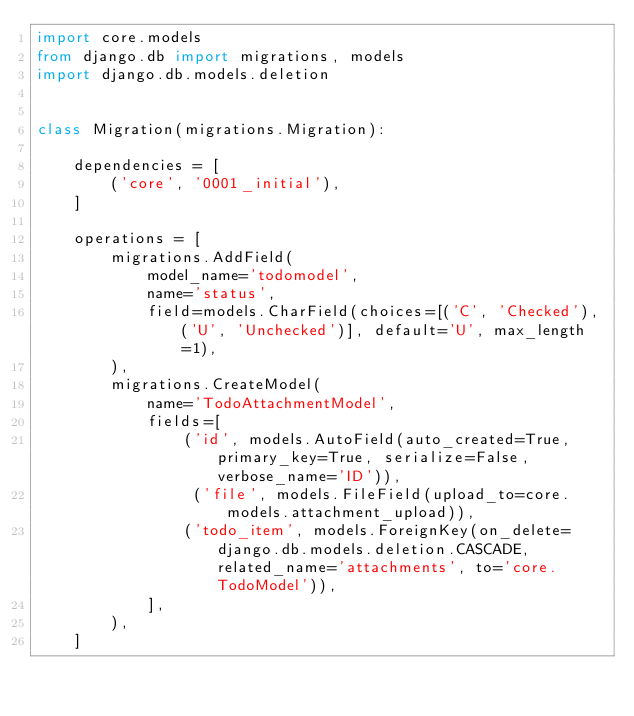<code> <loc_0><loc_0><loc_500><loc_500><_Python_>import core.models
from django.db import migrations, models
import django.db.models.deletion


class Migration(migrations.Migration):

    dependencies = [
        ('core', '0001_initial'),
    ]

    operations = [
        migrations.AddField(
            model_name='todomodel',
            name='status',
            field=models.CharField(choices=[('C', 'Checked'), ('U', 'Unchecked')], default='U', max_length=1),
        ),
        migrations.CreateModel(
            name='TodoAttachmentModel',
            fields=[
                ('id', models.AutoField(auto_created=True, primary_key=True, serialize=False, verbose_name='ID')),
                 ('file', models.FileField(upload_to=core.models.attachment_upload)),
                ('todo_item', models.ForeignKey(on_delete=django.db.models.deletion.CASCADE, related_name='attachments', to='core.TodoModel')),
            ],
        ),
    ]
</code> 